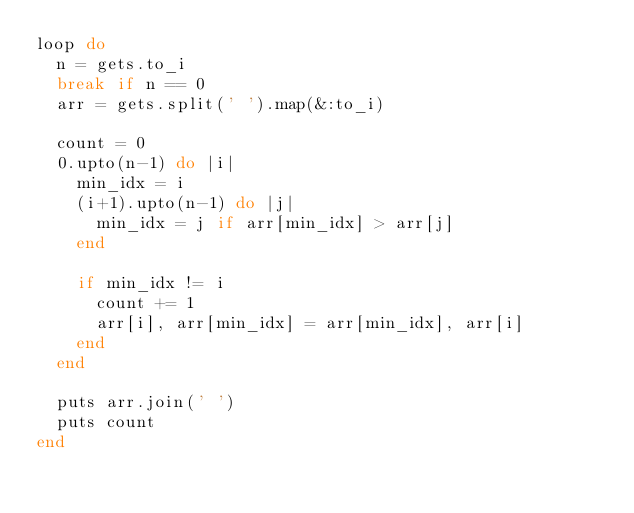<code> <loc_0><loc_0><loc_500><loc_500><_Ruby_>loop do
  n = gets.to_i
  break if n == 0
  arr = gets.split(' ').map(&:to_i)

  count = 0
  0.upto(n-1) do |i|
    min_idx = i
    (i+1).upto(n-1) do |j|
      min_idx = j if arr[min_idx] > arr[j]
    end

    if min_idx != i
      count += 1
      arr[i], arr[min_idx] = arr[min_idx], arr[i]
    end
  end

  puts arr.join(' ')
  puts count
end</code> 